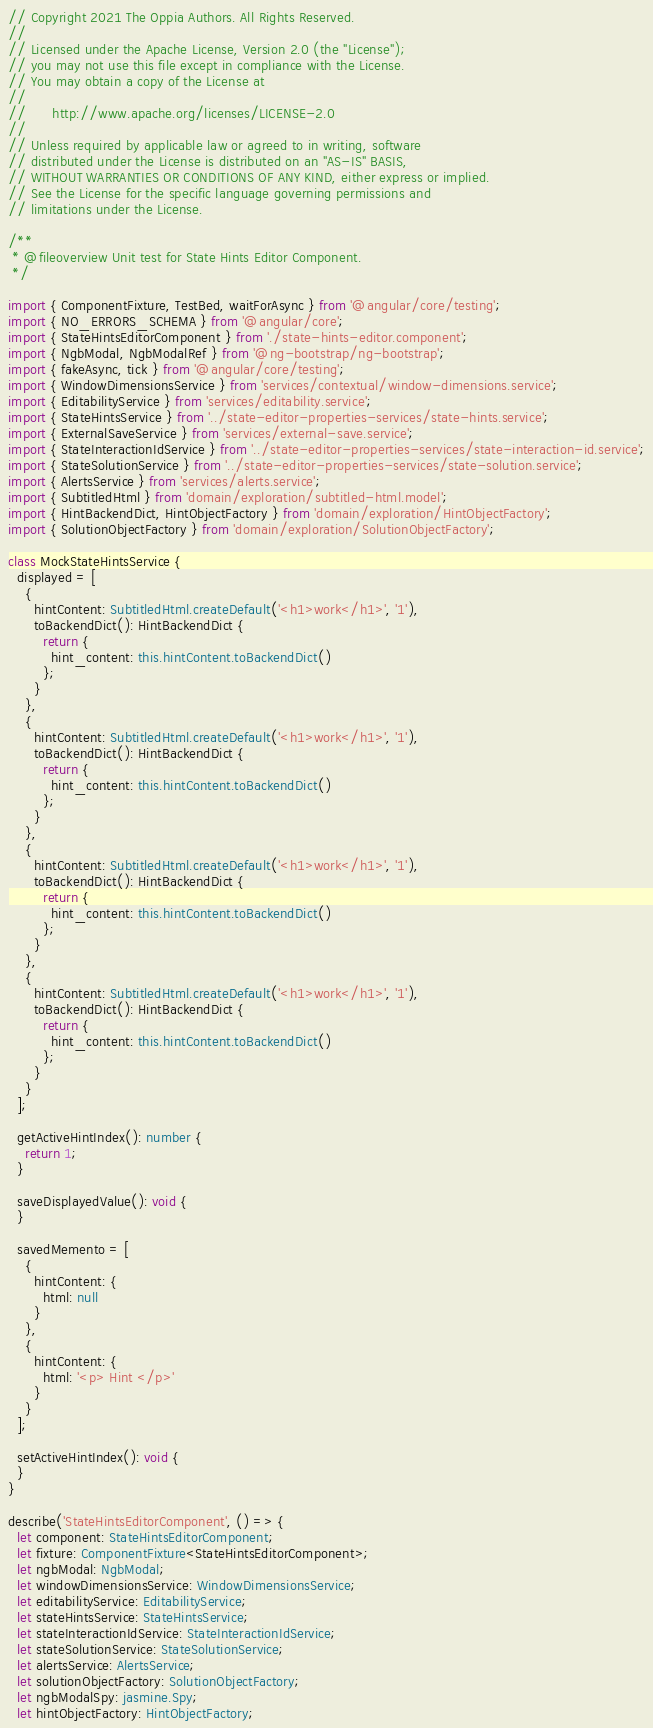<code> <loc_0><loc_0><loc_500><loc_500><_TypeScript_>// Copyright 2021 The Oppia Authors. All Rights Reserved.
//
// Licensed under the Apache License, Version 2.0 (the "License");
// you may not use this file except in compliance with the License.
// You may obtain a copy of the License at
//
//      http://www.apache.org/licenses/LICENSE-2.0
//
// Unless required by applicable law or agreed to in writing, software
// distributed under the License is distributed on an "AS-IS" BASIS,
// WITHOUT WARRANTIES OR CONDITIONS OF ANY KIND, either express or implied.
// See the License for the specific language governing permissions and
// limitations under the License.

/**
 * @fileoverview Unit test for State Hints Editor Component.
 */

import { ComponentFixture, TestBed, waitForAsync } from '@angular/core/testing';
import { NO_ERRORS_SCHEMA } from '@angular/core';
import { StateHintsEditorComponent } from './state-hints-editor.component';
import { NgbModal, NgbModalRef } from '@ng-bootstrap/ng-bootstrap';
import { fakeAsync, tick } from '@angular/core/testing';
import { WindowDimensionsService } from 'services/contextual/window-dimensions.service';
import { EditabilityService } from 'services/editability.service';
import { StateHintsService } from '../state-editor-properties-services/state-hints.service';
import { ExternalSaveService } from 'services/external-save.service';
import { StateInteractionIdService } from '../state-editor-properties-services/state-interaction-id.service';
import { StateSolutionService } from '../state-editor-properties-services/state-solution.service';
import { AlertsService } from 'services/alerts.service';
import { SubtitledHtml } from 'domain/exploration/subtitled-html.model';
import { HintBackendDict, HintObjectFactory } from 'domain/exploration/HintObjectFactory';
import { SolutionObjectFactory } from 'domain/exploration/SolutionObjectFactory';

class MockStateHintsService {
  displayed = [
    {
      hintContent: SubtitledHtml.createDefault('<h1>work</h1>', '1'),
      toBackendDict(): HintBackendDict {
        return {
          hint_content: this.hintContent.toBackendDict()
        };
      }
    },
    {
      hintContent: SubtitledHtml.createDefault('<h1>work</h1>', '1'),
      toBackendDict(): HintBackendDict {
        return {
          hint_content: this.hintContent.toBackendDict()
        };
      }
    },
    {
      hintContent: SubtitledHtml.createDefault('<h1>work</h1>', '1'),
      toBackendDict(): HintBackendDict {
        return {
          hint_content: this.hintContent.toBackendDict()
        };
      }
    },
    {
      hintContent: SubtitledHtml.createDefault('<h1>work</h1>', '1'),
      toBackendDict(): HintBackendDict {
        return {
          hint_content: this.hintContent.toBackendDict()
        };
      }
    }
  ];

  getActiveHintIndex(): number {
    return 1;
  }

  saveDisplayedValue(): void {
  }

  savedMemento = [
    {
      hintContent: {
        html: null
      }
    },
    {
      hintContent: {
        html: '<p> Hint </p>'
      }
    }
  ];

  setActiveHintIndex(): void {
  }
}

describe('StateHintsEditorComponent', () => {
  let component: StateHintsEditorComponent;
  let fixture: ComponentFixture<StateHintsEditorComponent>;
  let ngbModal: NgbModal;
  let windowDimensionsService: WindowDimensionsService;
  let editabilityService: EditabilityService;
  let stateHintsService: StateHintsService;
  let stateInteractionIdService: StateInteractionIdService;
  let stateSolutionService: StateSolutionService;
  let alertsService: AlertsService;
  let solutionObjectFactory: SolutionObjectFactory;
  let ngbModalSpy: jasmine.Spy;
  let hintObjectFactory: HintObjectFactory;
</code> 